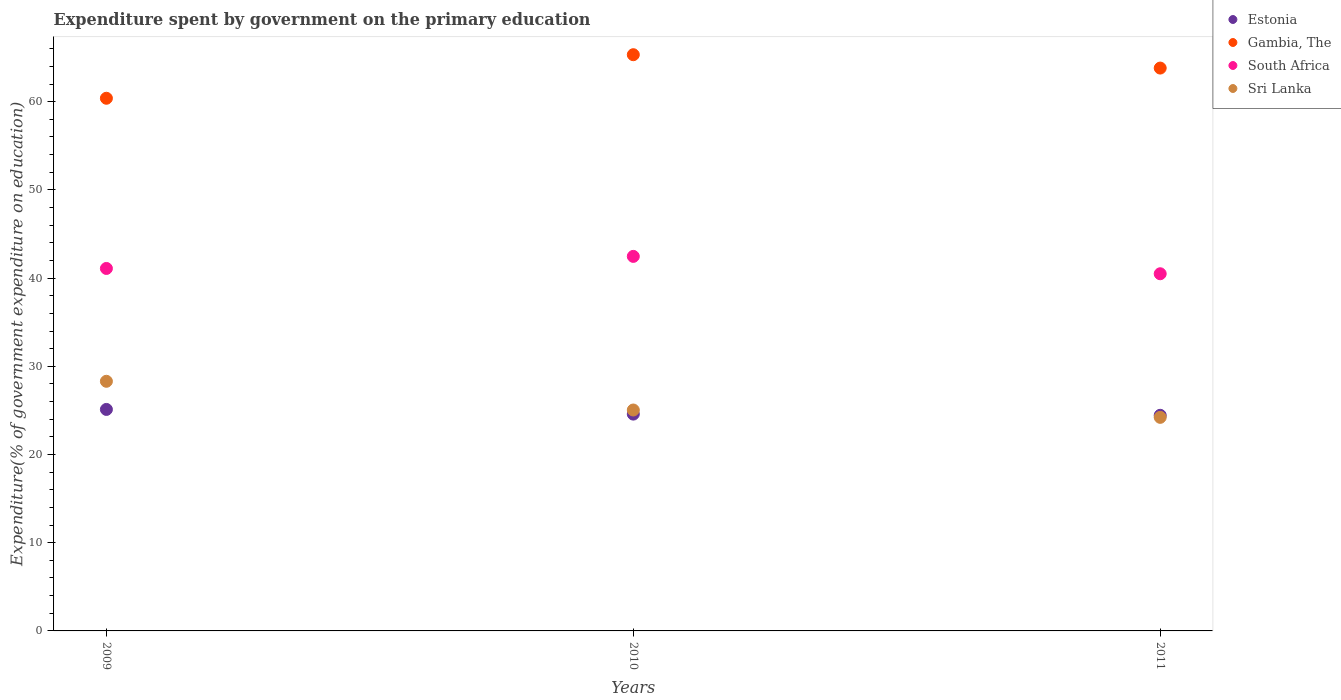What is the expenditure spent by government on the primary education in Sri Lanka in 2009?
Provide a short and direct response. 28.3. Across all years, what is the maximum expenditure spent by government on the primary education in Sri Lanka?
Offer a terse response. 28.3. Across all years, what is the minimum expenditure spent by government on the primary education in Sri Lanka?
Make the answer very short. 24.21. In which year was the expenditure spent by government on the primary education in Gambia, The maximum?
Your answer should be compact. 2010. What is the total expenditure spent by government on the primary education in Gambia, The in the graph?
Your answer should be very brief. 189.53. What is the difference between the expenditure spent by government on the primary education in Estonia in 2009 and that in 2010?
Provide a short and direct response. 0.53. What is the difference between the expenditure spent by government on the primary education in Gambia, The in 2011 and the expenditure spent by government on the primary education in Sri Lanka in 2009?
Your response must be concise. 35.51. What is the average expenditure spent by government on the primary education in Sri Lanka per year?
Your response must be concise. 25.85. In the year 2010, what is the difference between the expenditure spent by government on the primary education in Gambia, The and expenditure spent by government on the primary education in Sri Lanka?
Offer a very short reply. 40.28. What is the ratio of the expenditure spent by government on the primary education in Gambia, The in 2009 to that in 2010?
Offer a terse response. 0.92. What is the difference between the highest and the second highest expenditure spent by government on the primary education in Estonia?
Your answer should be very brief. 0.53. What is the difference between the highest and the lowest expenditure spent by government on the primary education in Estonia?
Your answer should be very brief. 0.67. In how many years, is the expenditure spent by government on the primary education in South Africa greater than the average expenditure spent by government on the primary education in South Africa taken over all years?
Keep it short and to the point. 1. Is the sum of the expenditure spent by government on the primary education in Estonia in 2009 and 2010 greater than the maximum expenditure spent by government on the primary education in South Africa across all years?
Your answer should be very brief. Yes. Is it the case that in every year, the sum of the expenditure spent by government on the primary education in South Africa and expenditure spent by government on the primary education in Sri Lanka  is greater than the sum of expenditure spent by government on the primary education in Gambia, The and expenditure spent by government on the primary education in Estonia?
Give a very brief answer. Yes. Is it the case that in every year, the sum of the expenditure spent by government on the primary education in Gambia, The and expenditure spent by government on the primary education in Sri Lanka  is greater than the expenditure spent by government on the primary education in South Africa?
Give a very brief answer. Yes. Does the expenditure spent by government on the primary education in South Africa monotonically increase over the years?
Offer a very short reply. No. Is the expenditure spent by government on the primary education in Estonia strictly greater than the expenditure spent by government on the primary education in South Africa over the years?
Keep it short and to the point. No. Is the expenditure spent by government on the primary education in South Africa strictly less than the expenditure spent by government on the primary education in Gambia, The over the years?
Offer a very short reply. Yes. How many years are there in the graph?
Your answer should be very brief. 3. Are the values on the major ticks of Y-axis written in scientific E-notation?
Ensure brevity in your answer.  No. Does the graph contain any zero values?
Keep it short and to the point. No. Does the graph contain grids?
Offer a very short reply. No. How are the legend labels stacked?
Offer a terse response. Vertical. What is the title of the graph?
Your response must be concise. Expenditure spent by government on the primary education. Does "High income" appear as one of the legend labels in the graph?
Give a very brief answer. No. What is the label or title of the Y-axis?
Give a very brief answer. Expenditure(% of government expenditure on education). What is the Expenditure(% of government expenditure on education) in Estonia in 2009?
Make the answer very short. 25.11. What is the Expenditure(% of government expenditure on education) in Gambia, The in 2009?
Offer a very short reply. 60.39. What is the Expenditure(% of government expenditure on education) of South Africa in 2009?
Your response must be concise. 41.09. What is the Expenditure(% of government expenditure on education) in Sri Lanka in 2009?
Provide a short and direct response. 28.3. What is the Expenditure(% of government expenditure on education) of Estonia in 2010?
Your response must be concise. 24.58. What is the Expenditure(% of government expenditure on education) in Gambia, The in 2010?
Your response must be concise. 65.33. What is the Expenditure(% of government expenditure on education) of South Africa in 2010?
Provide a succinct answer. 42.46. What is the Expenditure(% of government expenditure on education) of Sri Lanka in 2010?
Your answer should be compact. 25.05. What is the Expenditure(% of government expenditure on education) of Estonia in 2011?
Your response must be concise. 24.45. What is the Expenditure(% of government expenditure on education) of Gambia, The in 2011?
Your answer should be very brief. 63.81. What is the Expenditure(% of government expenditure on education) in South Africa in 2011?
Offer a terse response. 40.49. What is the Expenditure(% of government expenditure on education) in Sri Lanka in 2011?
Keep it short and to the point. 24.21. Across all years, what is the maximum Expenditure(% of government expenditure on education) of Estonia?
Your answer should be very brief. 25.11. Across all years, what is the maximum Expenditure(% of government expenditure on education) in Gambia, The?
Ensure brevity in your answer.  65.33. Across all years, what is the maximum Expenditure(% of government expenditure on education) of South Africa?
Offer a very short reply. 42.46. Across all years, what is the maximum Expenditure(% of government expenditure on education) in Sri Lanka?
Your answer should be compact. 28.3. Across all years, what is the minimum Expenditure(% of government expenditure on education) in Estonia?
Keep it short and to the point. 24.45. Across all years, what is the minimum Expenditure(% of government expenditure on education) in Gambia, The?
Offer a terse response. 60.39. Across all years, what is the minimum Expenditure(% of government expenditure on education) in South Africa?
Provide a short and direct response. 40.49. Across all years, what is the minimum Expenditure(% of government expenditure on education) of Sri Lanka?
Provide a short and direct response. 24.21. What is the total Expenditure(% of government expenditure on education) in Estonia in the graph?
Your answer should be compact. 74.14. What is the total Expenditure(% of government expenditure on education) in Gambia, The in the graph?
Your answer should be very brief. 189.53. What is the total Expenditure(% of government expenditure on education) of South Africa in the graph?
Your response must be concise. 124.05. What is the total Expenditure(% of government expenditure on education) in Sri Lanka in the graph?
Your answer should be very brief. 77.56. What is the difference between the Expenditure(% of government expenditure on education) of Estonia in 2009 and that in 2010?
Provide a succinct answer. 0.53. What is the difference between the Expenditure(% of government expenditure on education) of Gambia, The in 2009 and that in 2010?
Give a very brief answer. -4.94. What is the difference between the Expenditure(% of government expenditure on education) in South Africa in 2009 and that in 2010?
Your answer should be compact. -1.37. What is the difference between the Expenditure(% of government expenditure on education) of Sri Lanka in 2009 and that in 2010?
Your response must be concise. 3.25. What is the difference between the Expenditure(% of government expenditure on education) in Estonia in 2009 and that in 2011?
Your response must be concise. 0.67. What is the difference between the Expenditure(% of government expenditure on education) in Gambia, The in 2009 and that in 2011?
Your response must be concise. -3.42. What is the difference between the Expenditure(% of government expenditure on education) in South Africa in 2009 and that in 2011?
Make the answer very short. 0.6. What is the difference between the Expenditure(% of government expenditure on education) in Sri Lanka in 2009 and that in 2011?
Make the answer very short. 4.09. What is the difference between the Expenditure(% of government expenditure on education) of Estonia in 2010 and that in 2011?
Provide a short and direct response. 0.14. What is the difference between the Expenditure(% of government expenditure on education) of Gambia, The in 2010 and that in 2011?
Your response must be concise. 1.52. What is the difference between the Expenditure(% of government expenditure on education) in South Africa in 2010 and that in 2011?
Offer a very short reply. 1.97. What is the difference between the Expenditure(% of government expenditure on education) of Sri Lanka in 2010 and that in 2011?
Make the answer very short. 0.83. What is the difference between the Expenditure(% of government expenditure on education) in Estonia in 2009 and the Expenditure(% of government expenditure on education) in Gambia, The in 2010?
Offer a terse response. -40.22. What is the difference between the Expenditure(% of government expenditure on education) of Estonia in 2009 and the Expenditure(% of government expenditure on education) of South Africa in 2010?
Offer a very short reply. -17.35. What is the difference between the Expenditure(% of government expenditure on education) of Estonia in 2009 and the Expenditure(% of government expenditure on education) of Sri Lanka in 2010?
Provide a succinct answer. 0.07. What is the difference between the Expenditure(% of government expenditure on education) of Gambia, The in 2009 and the Expenditure(% of government expenditure on education) of South Africa in 2010?
Give a very brief answer. 17.93. What is the difference between the Expenditure(% of government expenditure on education) of Gambia, The in 2009 and the Expenditure(% of government expenditure on education) of Sri Lanka in 2010?
Provide a succinct answer. 35.34. What is the difference between the Expenditure(% of government expenditure on education) of South Africa in 2009 and the Expenditure(% of government expenditure on education) of Sri Lanka in 2010?
Provide a succinct answer. 16.05. What is the difference between the Expenditure(% of government expenditure on education) of Estonia in 2009 and the Expenditure(% of government expenditure on education) of Gambia, The in 2011?
Offer a very short reply. -38.7. What is the difference between the Expenditure(% of government expenditure on education) in Estonia in 2009 and the Expenditure(% of government expenditure on education) in South Africa in 2011?
Your response must be concise. -15.38. What is the difference between the Expenditure(% of government expenditure on education) in Estonia in 2009 and the Expenditure(% of government expenditure on education) in Sri Lanka in 2011?
Give a very brief answer. 0.9. What is the difference between the Expenditure(% of government expenditure on education) in Gambia, The in 2009 and the Expenditure(% of government expenditure on education) in South Africa in 2011?
Ensure brevity in your answer.  19.9. What is the difference between the Expenditure(% of government expenditure on education) in Gambia, The in 2009 and the Expenditure(% of government expenditure on education) in Sri Lanka in 2011?
Ensure brevity in your answer.  36.18. What is the difference between the Expenditure(% of government expenditure on education) of South Africa in 2009 and the Expenditure(% of government expenditure on education) of Sri Lanka in 2011?
Offer a terse response. 16.88. What is the difference between the Expenditure(% of government expenditure on education) of Estonia in 2010 and the Expenditure(% of government expenditure on education) of Gambia, The in 2011?
Ensure brevity in your answer.  -39.23. What is the difference between the Expenditure(% of government expenditure on education) of Estonia in 2010 and the Expenditure(% of government expenditure on education) of South Africa in 2011?
Ensure brevity in your answer.  -15.91. What is the difference between the Expenditure(% of government expenditure on education) of Estonia in 2010 and the Expenditure(% of government expenditure on education) of Sri Lanka in 2011?
Your answer should be compact. 0.37. What is the difference between the Expenditure(% of government expenditure on education) of Gambia, The in 2010 and the Expenditure(% of government expenditure on education) of South Africa in 2011?
Give a very brief answer. 24.83. What is the difference between the Expenditure(% of government expenditure on education) in Gambia, The in 2010 and the Expenditure(% of government expenditure on education) in Sri Lanka in 2011?
Give a very brief answer. 41.12. What is the difference between the Expenditure(% of government expenditure on education) in South Africa in 2010 and the Expenditure(% of government expenditure on education) in Sri Lanka in 2011?
Offer a very short reply. 18.25. What is the average Expenditure(% of government expenditure on education) in Estonia per year?
Provide a short and direct response. 24.71. What is the average Expenditure(% of government expenditure on education) in Gambia, The per year?
Offer a very short reply. 63.18. What is the average Expenditure(% of government expenditure on education) of South Africa per year?
Give a very brief answer. 41.35. What is the average Expenditure(% of government expenditure on education) in Sri Lanka per year?
Provide a succinct answer. 25.85. In the year 2009, what is the difference between the Expenditure(% of government expenditure on education) of Estonia and Expenditure(% of government expenditure on education) of Gambia, The?
Ensure brevity in your answer.  -35.28. In the year 2009, what is the difference between the Expenditure(% of government expenditure on education) in Estonia and Expenditure(% of government expenditure on education) in South Africa?
Your answer should be compact. -15.98. In the year 2009, what is the difference between the Expenditure(% of government expenditure on education) of Estonia and Expenditure(% of government expenditure on education) of Sri Lanka?
Make the answer very short. -3.19. In the year 2009, what is the difference between the Expenditure(% of government expenditure on education) in Gambia, The and Expenditure(% of government expenditure on education) in South Africa?
Keep it short and to the point. 19.3. In the year 2009, what is the difference between the Expenditure(% of government expenditure on education) of Gambia, The and Expenditure(% of government expenditure on education) of Sri Lanka?
Give a very brief answer. 32.09. In the year 2009, what is the difference between the Expenditure(% of government expenditure on education) in South Africa and Expenditure(% of government expenditure on education) in Sri Lanka?
Offer a terse response. 12.79. In the year 2010, what is the difference between the Expenditure(% of government expenditure on education) of Estonia and Expenditure(% of government expenditure on education) of Gambia, The?
Keep it short and to the point. -40.75. In the year 2010, what is the difference between the Expenditure(% of government expenditure on education) in Estonia and Expenditure(% of government expenditure on education) in South Africa?
Ensure brevity in your answer.  -17.88. In the year 2010, what is the difference between the Expenditure(% of government expenditure on education) in Estonia and Expenditure(% of government expenditure on education) in Sri Lanka?
Your answer should be very brief. -0.47. In the year 2010, what is the difference between the Expenditure(% of government expenditure on education) in Gambia, The and Expenditure(% of government expenditure on education) in South Africa?
Keep it short and to the point. 22.87. In the year 2010, what is the difference between the Expenditure(% of government expenditure on education) of Gambia, The and Expenditure(% of government expenditure on education) of Sri Lanka?
Your answer should be very brief. 40.28. In the year 2010, what is the difference between the Expenditure(% of government expenditure on education) in South Africa and Expenditure(% of government expenditure on education) in Sri Lanka?
Your answer should be compact. 17.42. In the year 2011, what is the difference between the Expenditure(% of government expenditure on education) in Estonia and Expenditure(% of government expenditure on education) in Gambia, The?
Offer a very short reply. -39.37. In the year 2011, what is the difference between the Expenditure(% of government expenditure on education) of Estonia and Expenditure(% of government expenditure on education) of South Africa?
Your response must be concise. -16.05. In the year 2011, what is the difference between the Expenditure(% of government expenditure on education) of Estonia and Expenditure(% of government expenditure on education) of Sri Lanka?
Provide a succinct answer. 0.23. In the year 2011, what is the difference between the Expenditure(% of government expenditure on education) in Gambia, The and Expenditure(% of government expenditure on education) in South Africa?
Your answer should be compact. 23.32. In the year 2011, what is the difference between the Expenditure(% of government expenditure on education) in Gambia, The and Expenditure(% of government expenditure on education) in Sri Lanka?
Give a very brief answer. 39.6. In the year 2011, what is the difference between the Expenditure(% of government expenditure on education) in South Africa and Expenditure(% of government expenditure on education) in Sri Lanka?
Provide a short and direct response. 16.28. What is the ratio of the Expenditure(% of government expenditure on education) of Estonia in 2009 to that in 2010?
Give a very brief answer. 1.02. What is the ratio of the Expenditure(% of government expenditure on education) in Gambia, The in 2009 to that in 2010?
Give a very brief answer. 0.92. What is the ratio of the Expenditure(% of government expenditure on education) in South Africa in 2009 to that in 2010?
Give a very brief answer. 0.97. What is the ratio of the Expenditure(% of government expenditure on education) in Sri Lanka in 2009 to that in 2010?
Offer a terse response. 1.13. What is the ratio of the Expenditure(% of government expenditure on education) in Estonia in 2009 to that in 2011?
Give a very brief answer. 1.03. What is the ratio of the Expenditure(% of government expenditure on education) of Gambia, The in 2009 to that in 2011?
Provide a succinct answer. 0.95. What is the ratio of the Expenditure(% of government expenditure on education) in South Africa in 2009 to that in 2011?
Keep it short and to the point. 1.01. What is the ratio of the Expenditure(% of government expenditure on education) in Sri Lanka in 2009 to that in 2011?
Your response must be concise. 1.17. What is the ratio of the Expenditure(% of government expenditure on education) of Estonia in 2010 to that in 2011?
Offer a terse response. 1.01. What is the ratio of the Expenditure(% of government expenditure on education) in Gambia, The in 2010 to that in 2011?
Your answer should be compact. 1.02. What is the ratio of the Expenditure(% of government expenditure on education) of South Africa in 2010 to that in 2011?
Your answer should be very brief. 1.05. What is the ratio of the Expenditure(% of government expenditure on education) in Sri Lanka in 2010 to that in 2011?
Give a very brief answer. 1.03. What is the difference between the highest and the second highest Expenditure(% of government expenditure on education) of Estonia?
Offer a terse response. 0.53. What is the difference between the highest and the second highest Expenditure(% of government expenditure on education) of Gambia, The?
Make the answer very short. 1.52. What is the difference between the highest and the second highest Expenditure(% of government expenditure on education) of South Africa?
Make the answer very short. 1.37. What is the difference between the highest and the second highest Expenditure(% of government expenditure on education) of Sri Lanka?
Offer a very short reply. 3.25. What is the difference between the highest and the lowest Expenditure(% of government expenditure on education) of Estonia?
Your answer should be compact. 0.67. What is the difference between the highest and the lowest Expenditure(% of government expenditure on education) of Gambia, The?
Your answer should be very brief. 4.94. What is the difference between the highest and the lowest Expenditure(% of government expenditure on education) in South Africa?
Offer a terse response. 1.97. What is the difference between the highest and the lowest Expenditure(% of government expenditure on education) of Sri Lanka?
Make the answer very short. 4.09. 